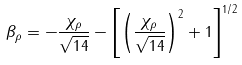<formula> <loc_0><loc_0><loc_500><loc_500>\beta _ { \rho } = - \frac { \chi _ { \rho } } { \sqrt { 1 4 } } - \left [ \left ( \frac { \chi _ { \rho } } { \sqrt { 1 4 } } \right ) ^ { 2 } + 1 \right ] ^ { 1 / 2 }</formula> 